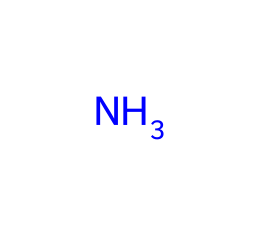What element is prominently featured in this chemical structure? The chemical structure clearly shows one nitrogen atom (N), which is the prominent element in ammonia.
Answer: nitrogen How many hydrogen atoms are typically associated with this nitrogen atom in ammonia? Ammonia (NH3) consists of one nitrogen atom bonded to three hydrogen atoms, which are essential for its structure.
Answer: three What type of bond is formed between the nitrogen and hydrogen atoms in ammonia? In ammonia, the nitrogen atom forms covalent bonds with each of the three hydrogen atoms, which is the typical bond type for such molecular structures.
Answer: covalent Why might ammonia be used in cleaning products for football equipment? Ammonia is a powerful cleaning agent known for its ability to break down tough stains and grime, making it suitable for cleaning athletic gear.
Answer: cleaning agent What property of ammonia contributes to its strong odor in cleaning products? The nitrogen atom in ammonia, alongside the triad of hydrogen atoms, contributes to its strong and pungent smell due to its volatile nature.
Answer: volatility Is ammonia classified as a weak or strong base? Ammonia is considered a weak base, as it partially ionizes in water, releasing hydroxide ions but not fully dissociating.
Answer: weak base What physical state is ammonia typically found in when used in cleaning products? Ammonia is usually found in a gaseous state or as an aqueous solution when used in various cleaning products.
Answer: gaseous or aqueous 